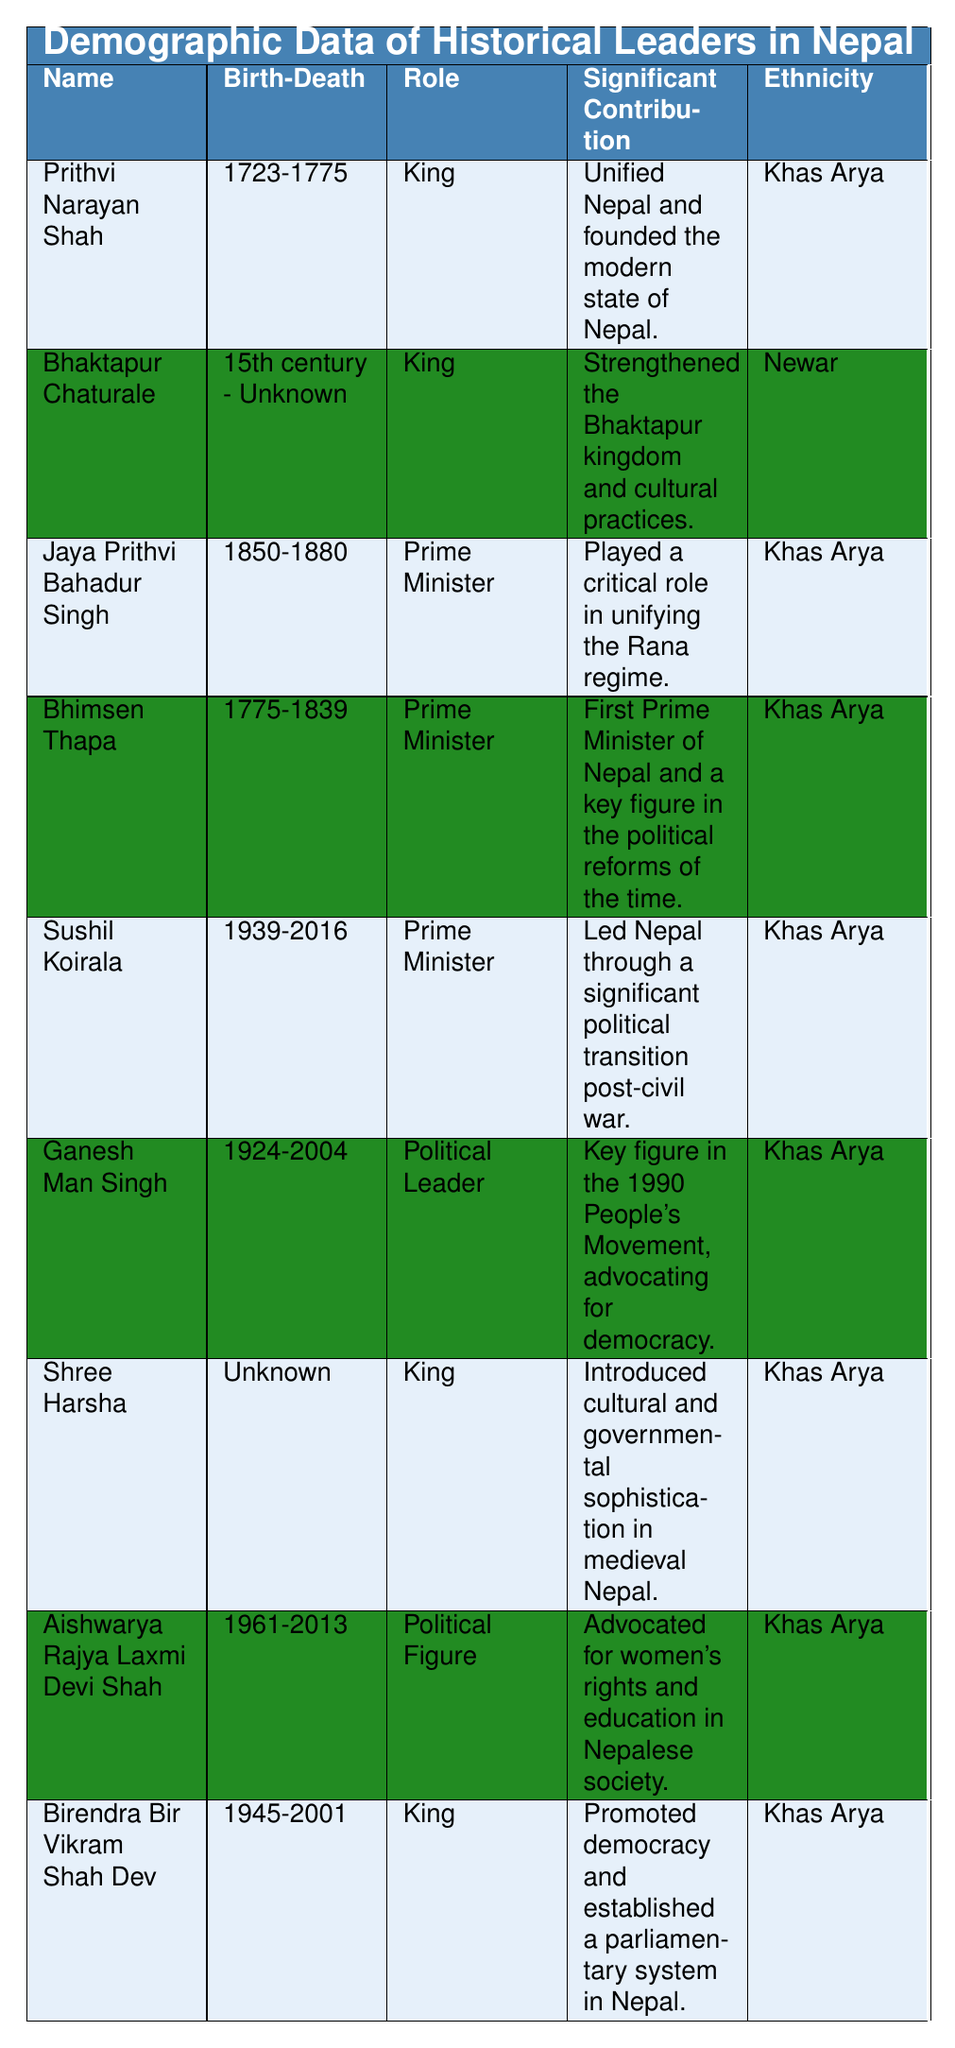What was the birth year of Prithvi Narayan Shah? The table lists Prithvi Narayan Shah's birth date as "1723-01-11", indicating he was born in the year 1723.
Answer: 1723 Who was the first Prime Minister of Nepal? According to the table, Bhimsen Thapa is noted as the first Prime Minister of Nepal.
Answer: Bhimsen Thapa Is Aishwarya Rajya Laxmi Devi Shah associated with women's rights advocacy? The table mentions that Aishwarya Rajya Laxmi Devi Shah advocated for women's rights and education in Nepalese society, which confirms the association.
Answer: Yes How many leaders in the table were born in the 20th century? The leaders born in the 20th century are Sushil Koirala (1939), Ganesh Man Singh (1924), and Aishwarya Rajya Laxmi Devi Shah (1961), totaling three leaders.
Answer: 3 Which role did Birendra Bir Vikram Shah Dev hold? The entry for Birendra Bir Vikram Shah Dev specifies that he was a King.
Answer: King Was Shree Harsha's death date known? The table clearly states that Shree Harsha's death date is listed as "Unknown", indicating that it is not known.
Answer: No What was the significant contribution of Jaya Prithvi Bahadur Singh? Jaya Prithvi Bahadur Singh's significant contribution, as per the table, is that he played a critical role in unifying the Rana regime.
Answer: Played a critical role in unifying the Rana regime Which ethnic group is represented the most among these leaders? The data shows that the "Khas Arya" ethnicity appears multiple times (five leaders) while "Newar" appears once, indicating that Khas Arya is the most represented group.
Answer: Khas Arya Did any leader in the table have an unknown birth place? Shree Harsha's birth place is stated as "Unknown" in the table, confirming that at least one leader has an unknown birth place.
Answer: Yes 